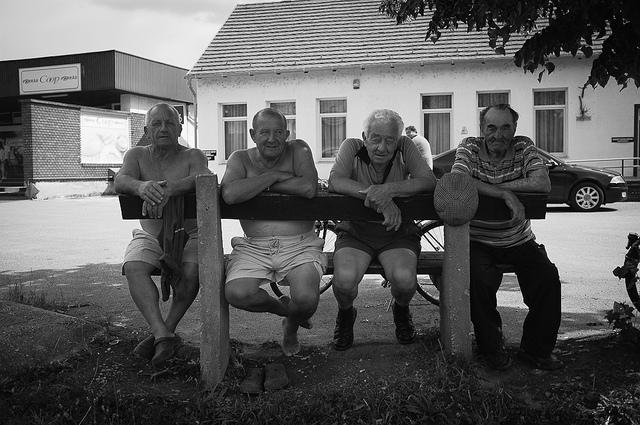What the shape of the half wall?
Answer briefly. Rectangle. Are there 4 young men on the bench?
Short answer required. No. How many persons are wear hats in this picture?
Short answer required. 0. How many people are there?
Write a very short answer. 4. How many men are shown?
Be succinct. 4. Whose family is this?
Write a very short answer. Men. What are the people looking at?
Keep it brief. Camera. What year was the photo taken?
Short answer required. 2000. Is this a crowded scene?
Write a very short answer. No. Are the people going on a trip?
Answer briefly. No. Are the men wearing hats?
Keep it brief. No. Is the temperature warm or cold?
Concise answer only. Warm. Are more people facing towards the camera or away from the camera?
Answer briefly. Towards. Are these people on a tour?
Keep it brief. No. Is anyone wearing sunglasses?
Be succinct. No. Are both of these people wearing long sleeve shirts?
Answer briefly. No. What are they standing in front of?
Short answer required. Building. What color are the walls?
Be succinct. White. How many people are posing for a photo?
Short answer required. 4. What are they sitting on?
Write a very short answer. Bench. What does the family keep as a pet?
Short answer required. Nothing. How many people are in the picture?
Give a very brief answer. 4. 